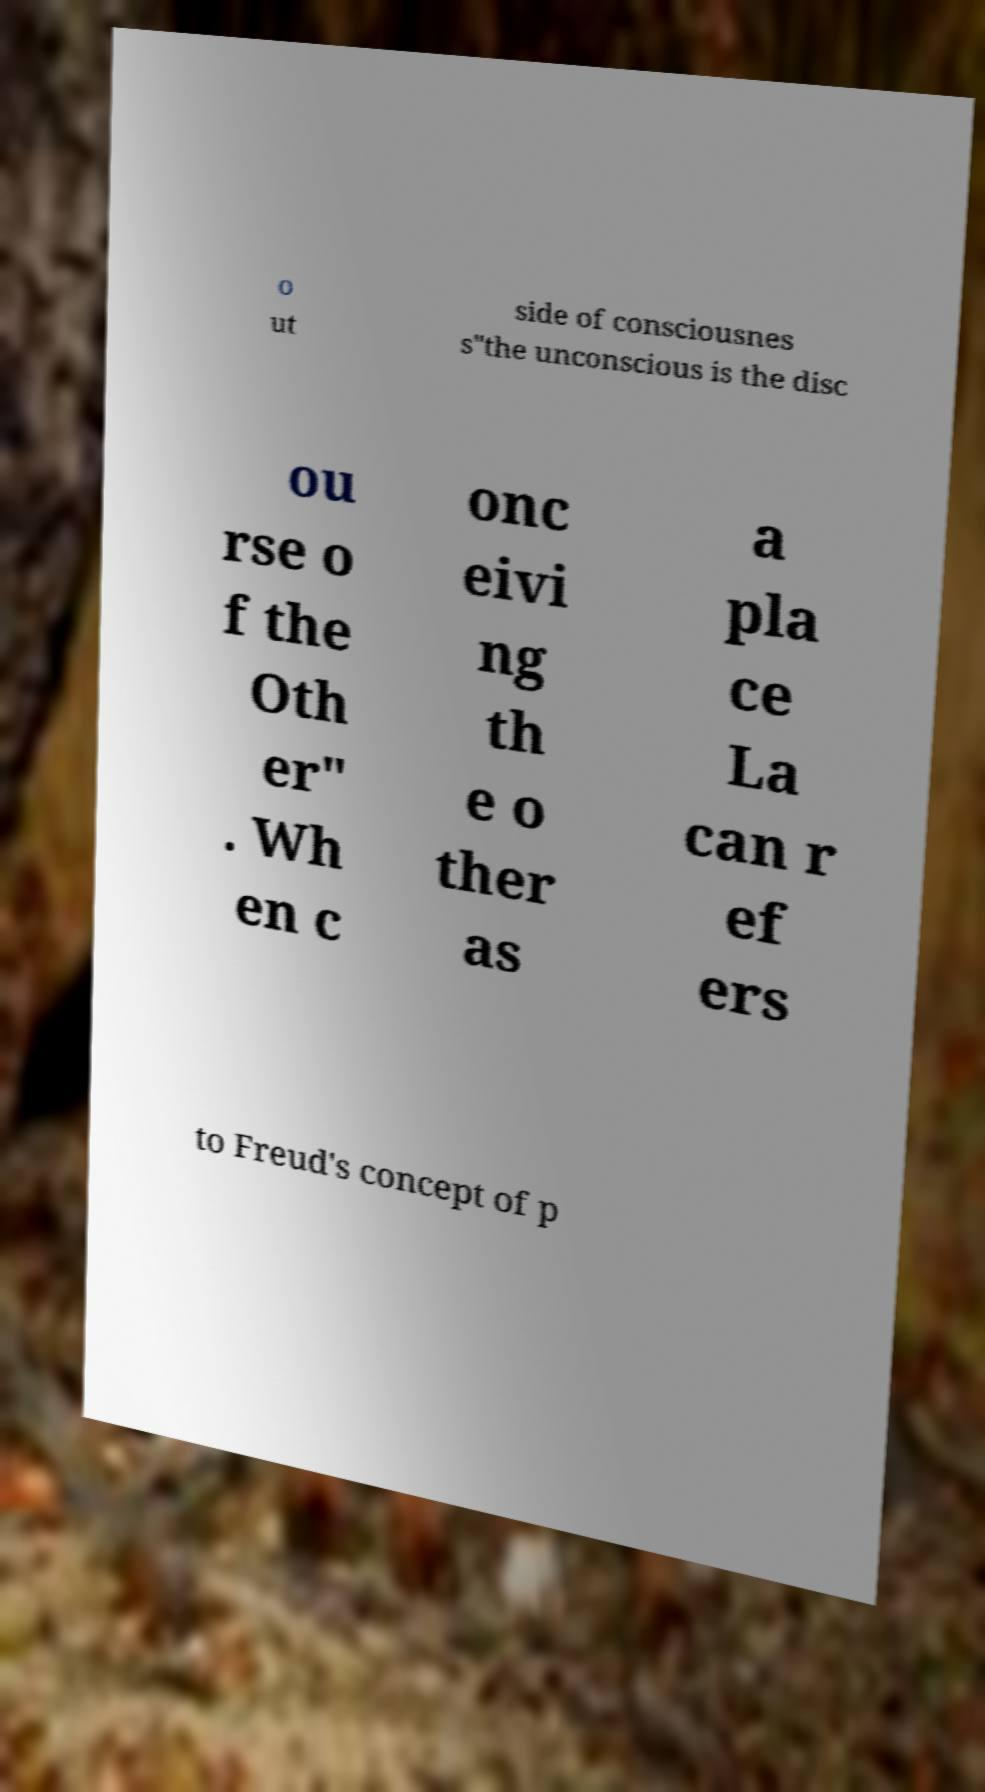Please identify and transcribe the text found in this image. o ut side of consciousnes s"the unconscious is the disc ou rse o f the Oth er" . Wh en c onc eivi ng th e o ther as a pla ce La can r ef ers to Freud's concept of p 